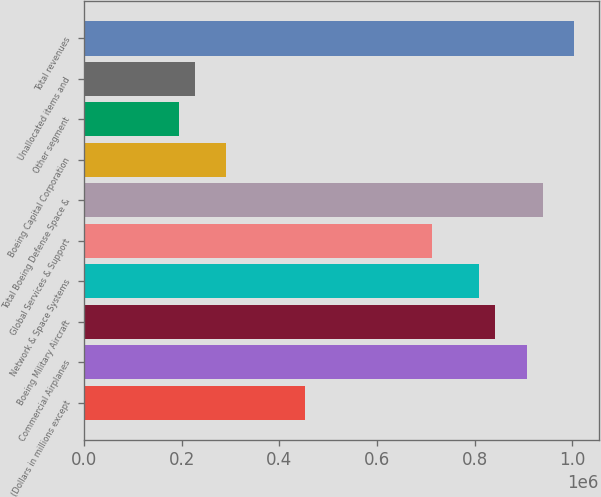<chart> <loc_0><loc_0><loc_500><loc_500><bar_chart><fcel>(Dollars in millions except<fcel>Commercial Airplanes<fcel>Boeing Military Aircraft<fcel>Network & Space Systems<fcel>Global Services & Support<fcel>Total Boeing Defense Space &<fcel>Boeing Capital Corporation<fcel>Other segment<fcel>Unallocated items and<fcel>Total revenues<nl><fcel>453403<fcel>906805<fcel>842033<fcel>809648<fcel>712490<fcel>939191<fcel>291474<fcel>194317<fcel>226702<fcel>1.00396e+06<nl></chart> 